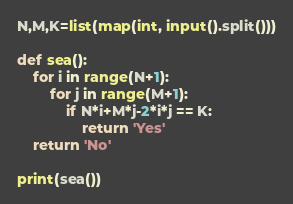<code> <loc_0><loc_0><loc_500><loc_500><_Python_>N,M,K=list(map(int, input().split()))

def sea():
    for i in range(N+1):
        for j in range(M+1):
            if N*i+M*j-2*i*j == K:
                return 'Yes'
    return 'No'

print(sea())</code> 